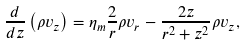<formula> <loc_0><loc_0><loc_500><loc_500>\frac { d } { d z } \left ( \rho v _ { z } \right ) = \eta _ { m } \frac { 2 } { r } \rho v _ { r } - \frac { 2 z } { r ^ { 2 } + z ^ { 2 } } \rho v _ { z } ,</formula> 